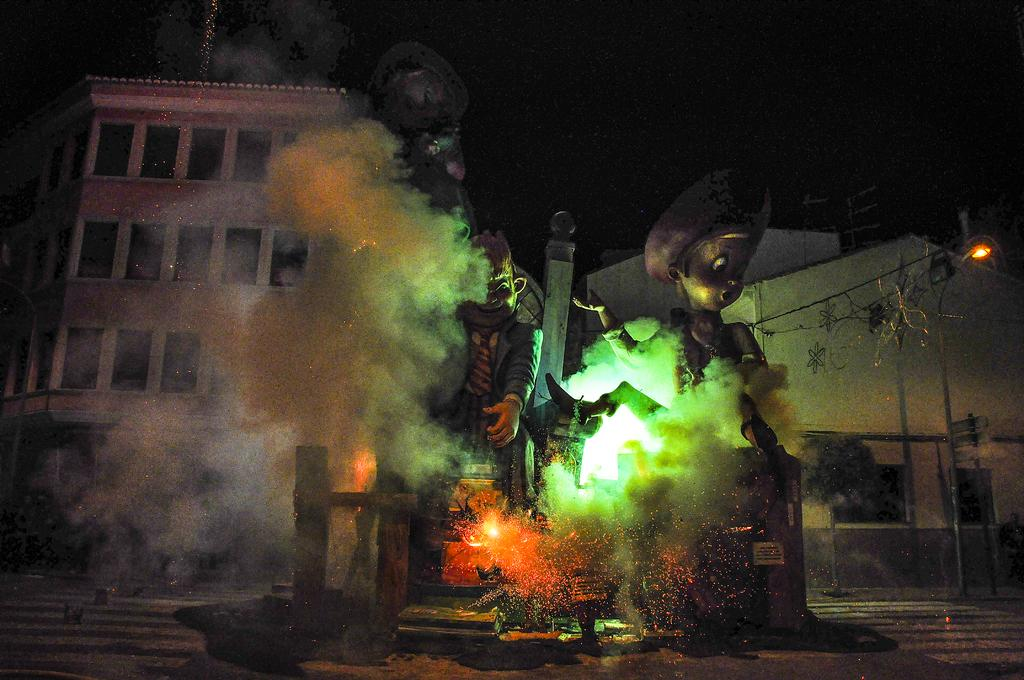What type of objects can be seen in the image? There are statues in the image. What architectural feature is present in the image? There are glass windows in the image. What type of structures are visible in the image? There are houses in the image. What is the color of the background in the image? The background of the image is dark. What type of treatment is being administered to the statues in the image? There is no treatment being administered to the statues in the image; they are stationary objects. What type of glass is visible in the image? The image only shows glass windows, not any specific type of glass. 